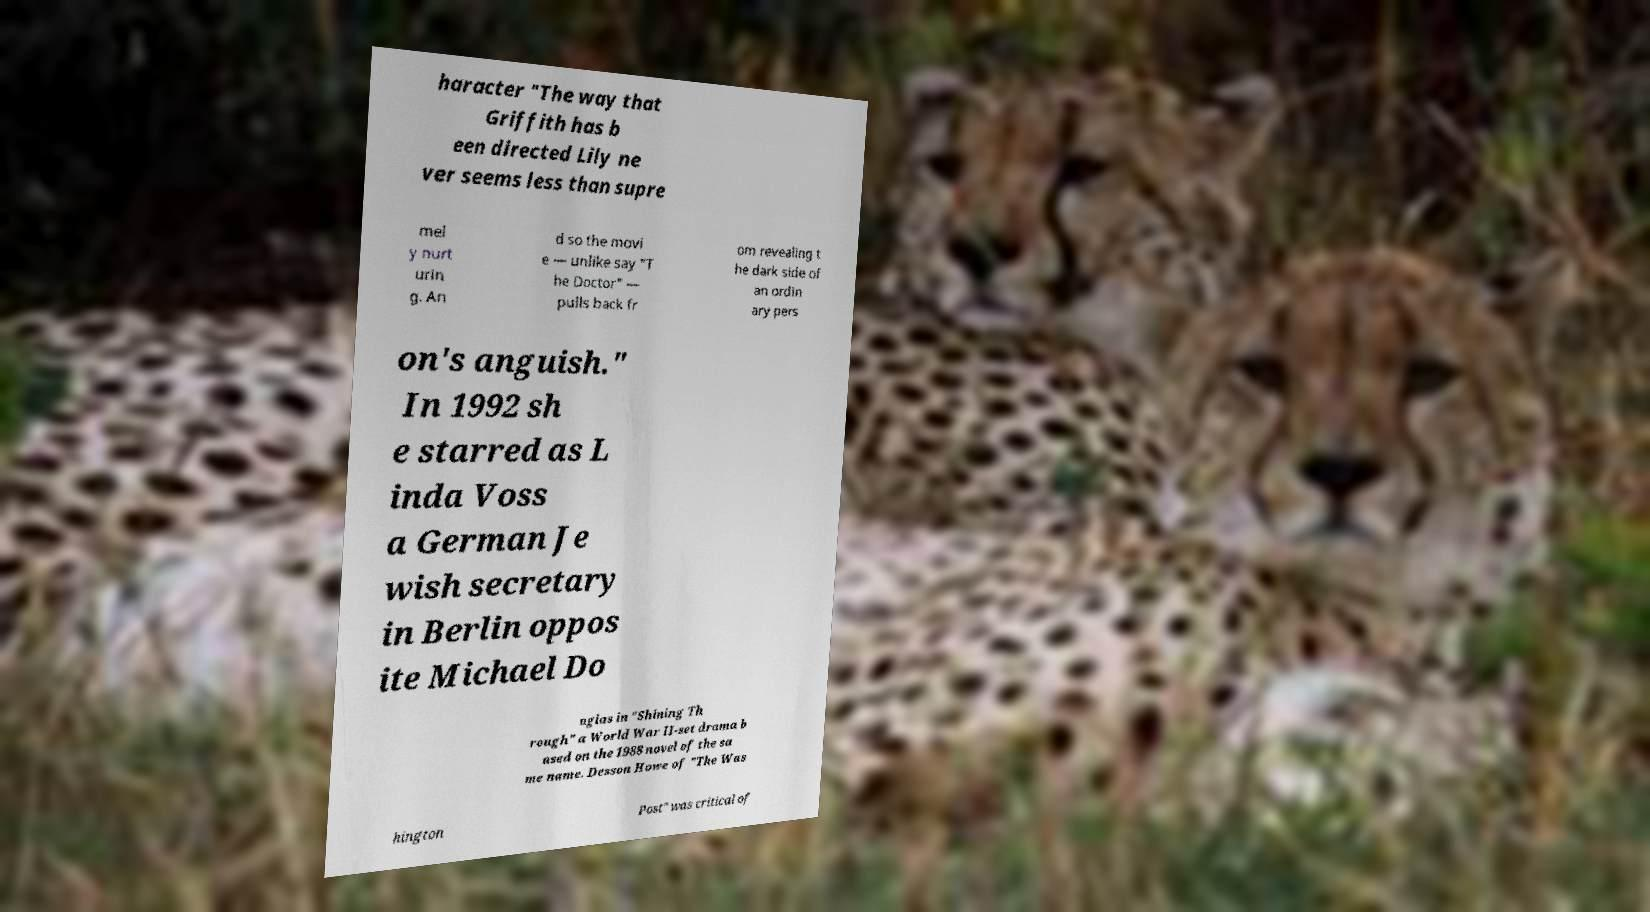Please identify and transcribe the text found in this image. haracter "The way that Griffith has b een directed Lily ne ver seems less than supre mel y nurt urin g. An d so the movi e — unlike say "T he Doctor" — pulls back fr om revealing t he dark side of an ordin ary pers on's anguish." In 1992 sh e starred as L inda Voss a German Je wish secretary in Berlin oppos ite Michael Do uglas in "Shining Th rough" a World War II-set drama b ased on the 1988 novel of the sa me name. Desson Howe of "The Was hington Post" was critical of 